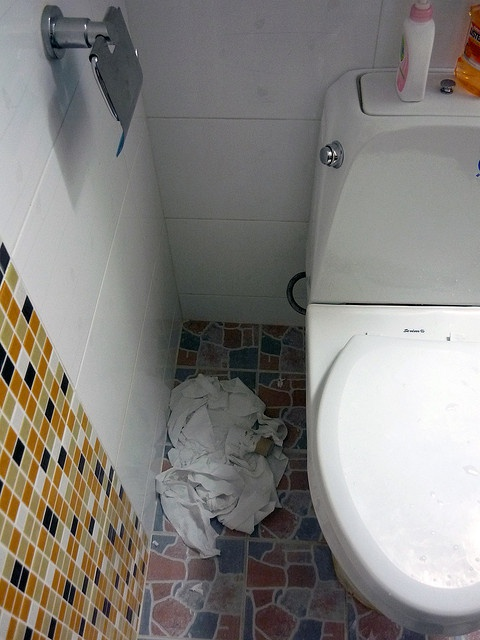Describe the objects in this image and their specific colors. I can see toilet in darkgray, white, gray, and black tones, bottle in darkgray and gray tones, and bottle in darkgray, maroon, and brown tones in this image. 